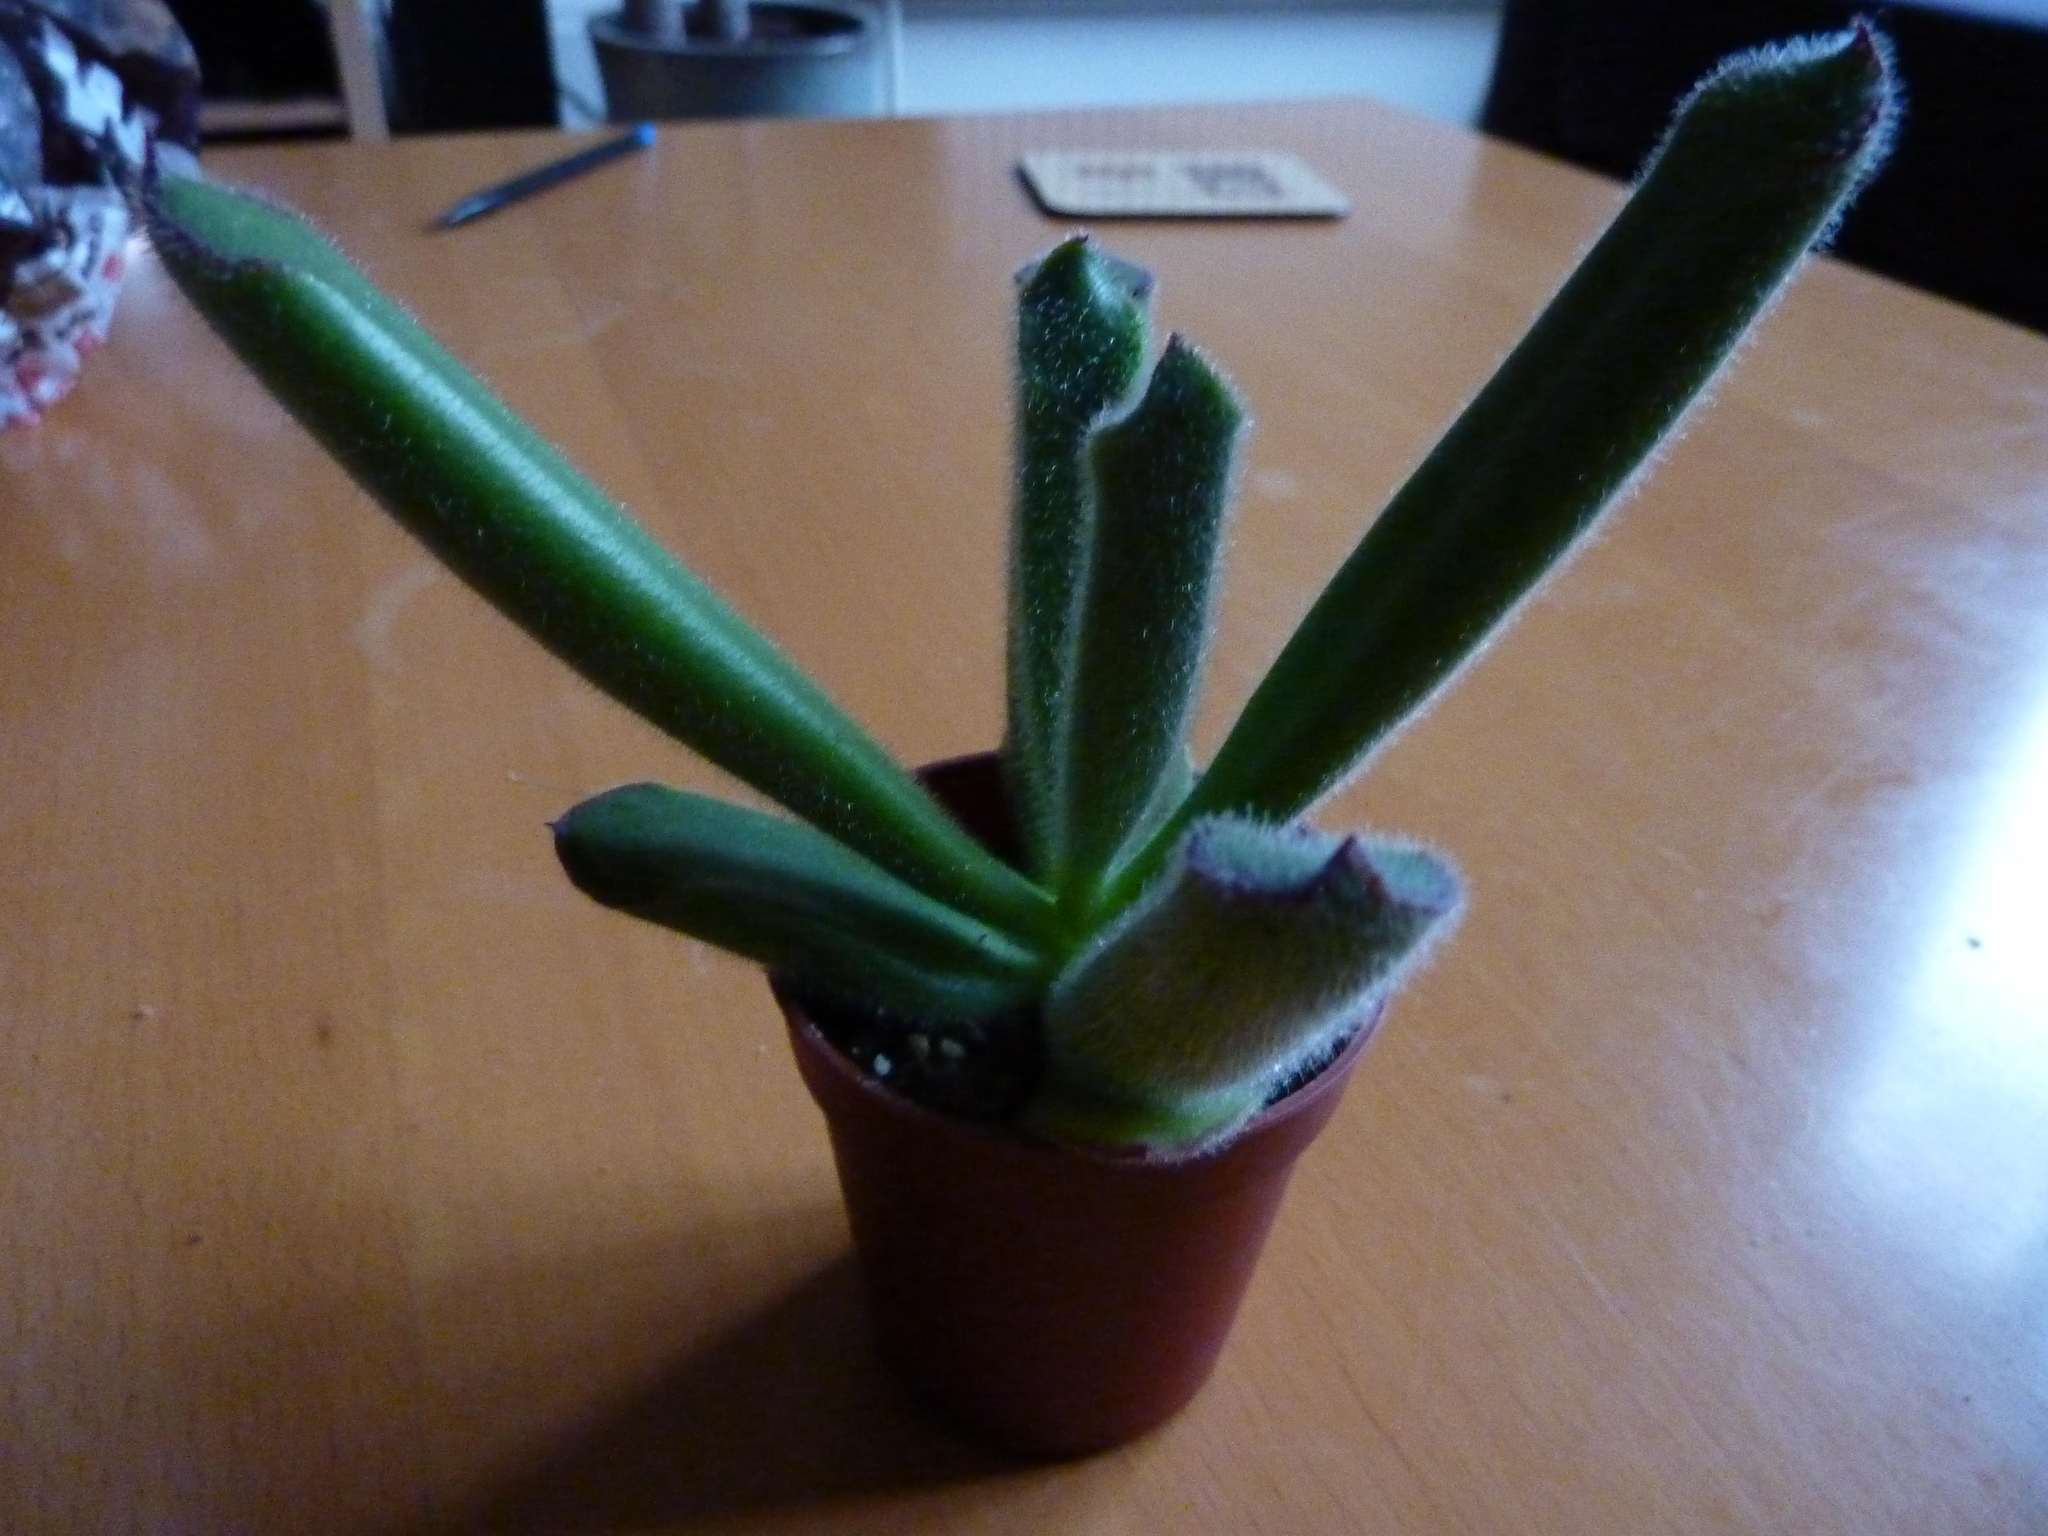What is the main subject in the center of the image? There is a houseplant in the center of the image. What can be seen in the background of the image? There is a pen in the background of the image. What type of furniture or surface is visible in the image? There are objects on a table in the image. What is used for waste disposal in the image? There is a bin in the image. What type of storage unit is present in the image? There is a cupboard in the image. What type of engine can be seen powering the houseplant in the image? There is no engine present in the image, and houseplants do not require engines to function. 